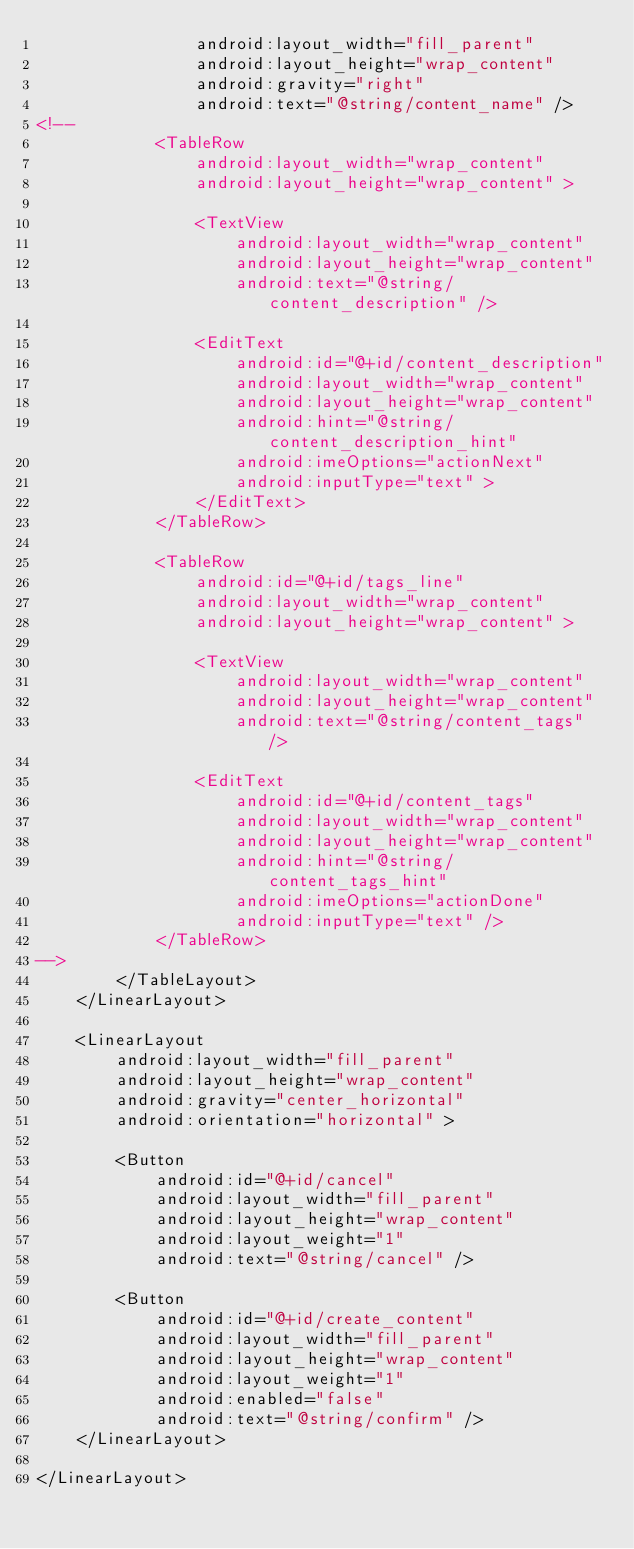<code> <loc_0><loc_0><loc_500><loc_500><_XML_>                android:layout_width="fill_parent"
                android:layout_height="wrap_content"
                android:gravity="right"
                android:text="@string/content_name" />
<!--
            <TableRow
                android:layout_width="wrap_content"
                android:layout_height="wrap_content" >

                <TextView
                    android:layout_width="wrap_content"
                    android:layout_height="wrap_content"
                    android:text="@string/content_description" />

                <EditText
                    android:id="@+id/content_description"
                    android:layout_width="wrap_content"
                    android:layout_height="wrap_content"
                    android:hint="@string/content_description_hint"
                    android:imeOptions="actionNext"
                    android:inputType="text" >
                </EditText>
            </TableRow>

            <TableRow
                android:id="@+id/tags_line"
                android:layout_width="wrap_content"
                android:layout_height="wrap_content" >

                <TextView
                    android:layout_width="wrap_content"
                    android:layout_height="wrap_content"
                    android:text="@string/content_tags" />

                <EditText
                    android:id="@+id/content_tags"
                    android:layout_width="wrap_content"
                    android:layout_height="wrap_content"
                    android:hint="@string/content_tags_hint"
                    android:imeOptions="actionDone"
                    android:inputType="text" />
            </TableRow>
-->
        </TableLayout>
    </LinearLayout>

    <LinearLayout
        android:layout_width="fill_parent"
        android:layout_height="wrap_content"
        android:gravity="center_horizontal"
        android:orientation="horizontal" >

        <Button
            android:id="@+id/cancel"
            android:layout_width="fill_parent"
            android:layout_height="wrap_content"
            android:layout_weight="1"
            android:text="@string/cancel" />

        <Button
            android:id="@+id/create_content"
            android:layout_width="fill_parent"
            android:layout_height="wrap_content"
            android:layout_weight="1"
            android:enabled="false"
            android:text="@string/confirm" />
    </LinearLayout>

</LinearLayout></code> 